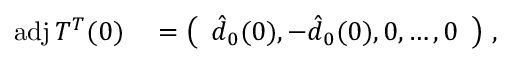Convert formula to latex. <formula><loc_0><loc_0><loc_500><loc_500>\begin{array} { r l } { a d j \, T ^ { T } ( 0 ) } & = \left ( \begin{array} { l } { \hat { d } _ { 0 } ( 0 ) , - \hat { d } _ { 0 } ( 0 ) , 0 , \dots , 0 } \end{array} \right ) \, , } \end{array}</formula> 